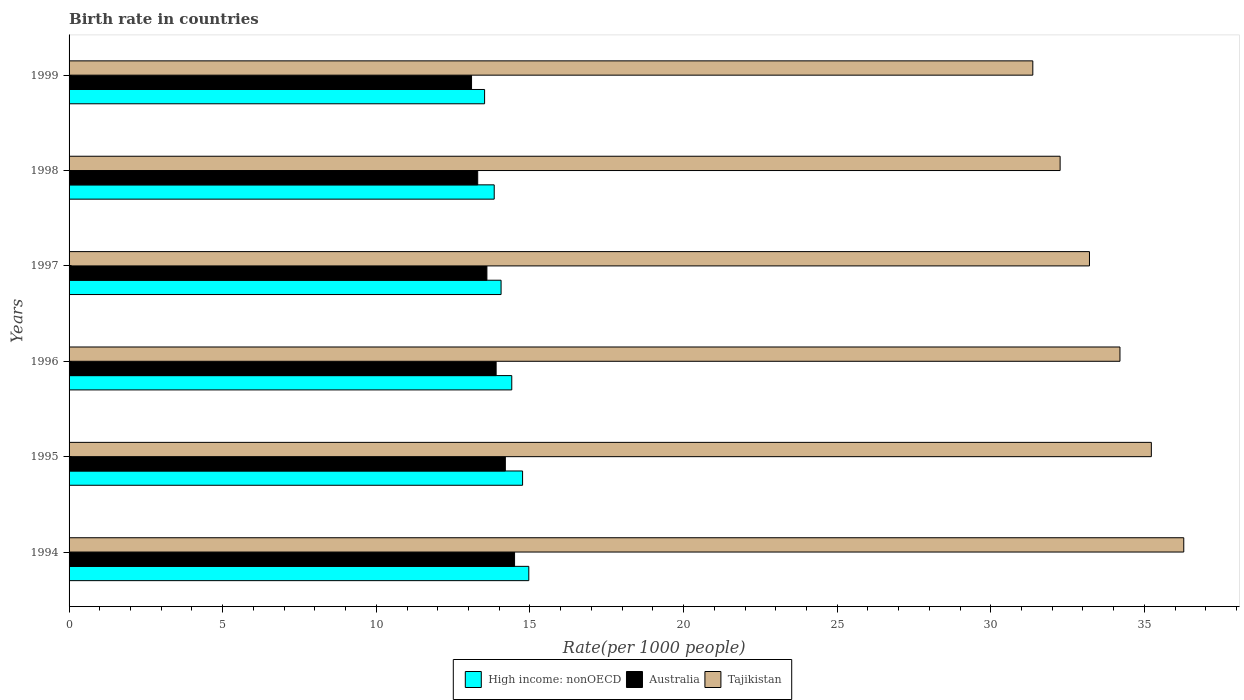In how many cases, is the number of bars for a given year not equal to the number of legend labels?
Ensure brevity in your answer.  0. What is the birth rate in Tajikistan in 1999?
Keep it short and to the point. 31.37. Across all years, what is the minimum birth rate in High income: nonOECD?
Ensure brevity in your answer.  13.52. In which year was the birth rate in Australia maximum?
Provide a short and direct response. 1994. What is the total birth rate in Tajikistan in the graph?
Ensure brevity in your answer.  202.55. What is the difference between the birth rate in Tajikistan in 1996 and that in 1998?
Provide a succinct answer. 1.95. What is the difference between the birth rate in Tajikistan in 1996 and the birth rate in Australia in 1995?
Your response must be concise. 20. What is the average birth rate in Australia per year?
Keep it short and to the point. 13.77. In the year 1995, what is the difference between the birth rate in Tajikistan and birth rate in Australia?
Keep it short and to the point. 21.03. What is the ratio of the birth rate in High income: nonOECD in 1995 to that in 1996?
Your answer should be very brief. 1.02. Is the difference between the birth rate in Tajikistan in 1995 and 1999 greater than the difference between the birth rate in Australia in 1995 and 1999?
Provide a short and direct response. Yes. What is the difference between the highest and the second highest birth rate in Australia?
Your answer should be compact. 0.3. What is the difference between the highest and the lowest birth rate in Tajikistan?
Your response must be concise. 4.91. Is the sum of the birth rate in High income: nonOECD in 1994 and 1998 greater than the maximum birth rate in Tajikistan across all years?
Give a very brief answer. No. What does the 3rd bar from the top in 1997 represents?
Offer a terse response. High income: nonOECD. What does the 3rd bar from the bottom in 1996 represents?
Keep it short and to the point. Tajikistan. How many years are there in the graph?
Provide a short and direct response. 6. Are the values on the major ticks of X-axis written in scientific E-notation?
Ensure brevity in your answer.  No. What is the title of the graph?
Your response must be concise. Birth rate in countries. Does "Maldives" appear as one of the legend labels in the graph?
Keep it short and to the point. No. What is the label or title of the X-axis?
Make the answer very short. Rate(per 1000 people). What is the label or title of the Y-axis?
Make the answer very short. Years. What is the Rate(per 1000 people) of High income: nonOECD in 1994?
Provide a short and direct response. 14.96. What is the Rate(per 1000 people) in Tajikistan in 1994?
Your answer should be compact. 36.28. What is the Rate(per 1000 people) in High income: nonOECD in 1995?
Make the answer very short. 14.76. What is the Rate(per 1000 people) in Australia in 1995?
Provide a succinct answer. 14.2. What is the Rate(per 1000 people) of Tajikistan in 1995?
Ensure brevity in your answer.  35.23. What is the Rate(per 1000 people) in High income: nonOECD in 1996?
Your answer should be compact. 14.41. What is the Rate(per 1000 people) in Australia in 1996?
Keep it short and to the point. 13.9. What is the Rate(per 1000 people) in Tajikistan in 1996?
Offer a very short reply. 34.2. What is the Rate(per 1000 people) of High income: nonOECD in 1997?
Offer a terse response. 14.06. What is the Rate(per 1000 people) of Tajikistan in 1997?
Provide a short and direct response. 33.21. What is the Rate(per 1000 people) in High income: nonOECD in 1998?
Provide a succinct answer. 13.84. What is the Rate(per 1000 people) of Australia in 1998?
Your answer should be very brief. 13.3. What is the Rate(per 1000 people) in Tajikistan in 1998?
Ensure brevity in your answer.  32.26. What is the Rate(per 1000 people) in High income: nonOECD in 1999?
Give a very brief answer. 13.52. What is the Rate(per 1000 people) of Tajikistan in 1999?
Offer a terse response. 31.37. Across all years, what is the maximum Rate(per 1000 people) of High income: nonOECD?
Your response must be concise. 14.96. Across all years, what is the maximum Rate(per 1000 people) of Australia?
Ensure brevity in your answer.  14.5. Across all years, what is the maximum Rate(per 1000 people) of Tajikistan?
Keep it short and to the point. 36.28. Across all years, what is the minimum Rate(per 1000 people) in High income: nonOECD?
Ensure brevity in your answer.  13.52. Across all years, what is the minimum Rate(per 1000 people) of Australia?
Make the answer very short. 13.1. Across all years, what is the minimum Rate(per 1000 people) in Tajikistan?
Provide a succinct answer. 31.37. What is the total Rate(per 1000 people) in High income: nonOECD in the graph?
Provide a succinct answer. 85.56. What is the total Rate(per 1000 people) in Australia in the graph?
Keep it short and to the point. 82.6. What is the total Rate(per 1000 people) of Tajikistan in the graph?
Offer a very short reply. 202.55. What is the difference between the Rate(per 1000 people) in High income: nonOECD in 1994 and that in 1995?
Your answer should be very brief. 0.2. What is the difference between the Rate(per 1000 people) in Tajikistan in 1994 and that in 1995?
Provide a short and direct response. 1.05. What is the difference between the Rate(per 1000 people) in High income: nonOECD in 1994 and that in 1996?
Your response must be concise. 0.55. What is the difference between the Rate(per 1000 people) of Tajikistan in 1994 and that in 1996?
Your answer should be very brief. 2.08. What is the difference between the Rate(per 1000 people) in High income: nonOECD in 1994 and that in 1997?
Provide a short and direct response. 0.9. What is the difference between the Rate(per 1000 people) of Tajikistan in 1994 and that in 1997?
Provide a succinct answer. 3.07. What is the difference between the Rate(per 1000 people) of High income: nonOECD in 1994 and that in 1998?
Your answer should be compact. 1.13. What is the difference between the Rate(per 1000 people) of Tajikistan in 1994 and that in 1998?
Offer a very short reply. 4.02. What is the difference between the Rate(per 1000 people) in High income: nonOECD in 1994 and that in 1999?
Provide a short and direct response. 1.44. What is the difference between the Rate(per 1000 people) of Australia in 1994 and that in 1999?
Your response must be concise. 1.4. What is the difference between the Rate(per 1000 people) in Tajikistan in 1994 and that in 1999?
Provide a succinct answer. 4.91. What is the difference between the Rate(per 1000 people) in High income: nonOECD in 1995 and that in 1996?
Your response must be concise. 0.35. What is the difference between the Rate(per 1000 people) in Australia in 1995 and that in 1996?
Your answer should be very brief. 0.3. What is the difference between the Rate(per 1000 people) of High income: nonOECD in 1995 and that in 1997?
Your answer should be compact. 0.7. What is the difference between the Rate(per 1000 people) in Tajikistan in 1995 and that in 1997?
Ensure brevity in your answer.  2.01. What is the difference between the Rate(per 1000 people) of High income: nonOECD in 1995 and that in 1998?
Offer a terse response. 0.92. What is the difference between the Rate(per 1000 people) of Australia in 1995 and that in 1998?
Offer a very short reply. 0.9. What is the difference between the Rate(per 1000 people) in Tajikistan in 1995 and that in 1998?
Give a very brief answer. 2.97. What is the difference between the Rate(per 1000 people) of High income: nonOECD in 1995 and that in 1999?
Ensure brevity in your answer.  1.24. What is the difference between the Rate(per 1000 people) of Tajikistan in 1995 and that in 1999?
Offer a terse response. 3.86. What is the difference between the Rate(per 1000 people) of High income: nonOECD in 1996 and that in 1997?
Provide a succinct answer. 0.35. What is the difference between the Rate(per 1000 people) in Tajikistan in 1996 and that in 1997?
Your answer should be compact. 0.99. What is the difference between the Rate(per 1000 people) in High income: nonOECD in 1996 and that in 1998?
Your response must be concise. 0.57. What is the difference between the Rate(per 1000 people) of Australia in 1996 and that in 1998?
Provide a succinct answer. 0.6. What is the difference between the Rate(per 1000 people) in Tajikistan in 1996 and that in 1998?
Provide a succinct answer. 1.95. What is the difference between the Rate(per 1000 people) of High income: nonOECD in 1996 and that in 1999?
Make the answer very short. 0.88. What is the difference between the Rate(per 1000 people) of Tajikistan in 1996 and that in 1999?
Your response must be concise. 2.84. What is the difference between the Rate(per 1000 people) of High income: nonOECD in 1997 and that in 1998?
Provide a succinct answer. 0.22. What is the difference between the Rate(per 1000 people) in Australia in 1997 and that in 1998?
Provide a short and direct response. 0.3. What is the difference between the Rate(per 1000 people) of Tajikistan in 1997 and that in 1998?
Give a very brief answer. 0.95. What is the difference between the Rate(per 1000 people) in High income: nonOECD in 1997 and that in 1999?
Ensure brevity in your answer.  0.54. What is the difference between the Rate(per 1000 people) of Tajikistan in 1997 and that in 1999?
Provide a short and direct response. 1.84. What is the difference between the Rate(per 1000 people) of High income: nonOECD in 1998 and that in 1999?
Give a very brief answer. 0.31. What is the difference between the Rate(per 1000 people) in Australia in 1998 and that in 1999?
Offer a terse response. 0.2. What is the difference between the Rate(per 1000 people) in Tajikistan in 1998 and that in 1999?
Your answer should be compact. 0.89. What is the difference between the Rate(per 1000 people) in High income: nonOECD in 1994 and the Rate(per 1000 people) in Australia in 1995?
Your response must be concise. 0.76. What is the difference between the Rate(per 1000 people) of High income: nonOECD in 1994 and the Rate(per 1000 people) of Tajikistan in 1995?
Provide a short and direct response. -20.26. What is the difference between the Rate(per 1000 people) in Australia in 1994 and the Rate(per 1000 people) in Tajikistan in 1995?
Give a very brief answer. -20.73. What is the difference between the Rate(per 1000 people) in High income: nonOECD in 1994 and the Rate(per 1000 people) in Australia in 1996?
Make the answer very short. 1.06. What is the difference between the Rate(per 1000 people) of High income: nonOECD in 1994 and the Rate(per 1000 people) of Tajikistan in 1996?
Ensure brevity in your answer.  -19.24. What is the difference between the Rate(per 1000 people) of Australia in 1994 and the Rate(per 1000 people) of Tajikistan in 1996?
Your response must be concise. -19.7. What is the difference between the Rate(per 1000 people) in High income: nonOECD in 1994 and the Rate(per 1000 people) in Australia in 1997?
Provide a short and direct response. 1.36. What is the difference between the Rate(per 1000 people) in High income: nonOECD in 1994 and the Rate(per 1000 people) in Tajikistan in 1997?
Offer a terse response. -18.25. What is the difference between the Rate(per 1000 people) in Australia in 1994 and the Rate(per 1000 people) in Tajikistan in 1997?
Provide a short and direct response. -18.71. What is the difference between the Rate(per 1000 people) in High income: nonOECD in 1994 and the Rate(per 1000 people) in Australia in 1998?
Give a very brief answer. 1.66. What is the difference between the Rate(per 1000 people) in High income: nonOECD in 1994 and the Rate(per 1000 people) in Tajikistan in 1998?
Make the answer very short. -17.29. What is the difference between the Rate(per 1000 people) in Australia in 1994 and the Rate(per 1000 people) in Tajikistan in 1998?
Provide a short and direct response. -17.76. What is the difference between the Rate(per 1000 people) in High income: nonOECD in 1994 and the Rate(per 1000 people) in Australia in 1999?
Your answer should be compact. 1.86. What is the difference between the Rate(per 1000 people) of High income: nonOECD in 1994 and the Rate(per 1000 people) of Tajikistan in 1999?
Give a very brief answer. -16.4. What is the difference between the Rate(per 1000 people) in Australia in 1994 and the Rate(per 1000 people) in Tajikistan in 1999?
Offer a very short reply. -16.87. What is the difference between the Rate(per 1000 people) in High income: nonOECD in 1995 and the Rate(per 1000 people) in Australia in 1996?
Your response must be concise. 0.86. What is the difference between the Rate(per 1000 people) of High income: nonOECD in 1995 and the Rate(per 1000 people) of Tajikistan in 1996?
Make the answer very short. -19.44. What is the difference between the Rate(per 1000 people) in Australia in 1995 and the Rate(per 1000 people) in Tajikistan in 1996?
Provide a succinct answer. -20. What is the difference between the Rate(per 1000 people) in High income: nonOECD in 1995 and the Rate(per 1000 people) in Australia in 1997?
Offer a terse response. 1.16. What is the difference between the Rate(per 1000 people) of High income: nonOECD in 1995 and the Rate(per 1000 people) of Tajikistan in 1997?
Your answer should be very brief. -18.45. What is the difference between the Rate(per 1000 people) of Australia in 1995 and the Rate(per 1000 people) of Tajikistan in 1997?
Make the answer very short. -19.01. What is the difference between the Rate(per 1000 people) of High income: nonOECD in 1995 and the Rate(per 1000 people) of Australia in 1998?
Offer a terse response. 1.46. What is the difference between the Rate(per 1000 people) in High income: nonOECD in 1995 and the Rate(per 1000 people) in Tajikistan in 1998?
Offer a very short reply. -17.5. What is the difference between the Rate(per 1000 people) in Australia in 1995 and the Rate(per 1000 people) in Tajikistan in 1998?
Your answer should be very brief. -18.06. What is the difference between the Rate(per 1000 people) in High income: nonOECD in 1995 and the Rate(per 1000 people) in Australia in 1999?
Provide a short and direct response. 1.66. What is the difference between the Rate(per 1000 people) of High income: nonOECD in 1995 and the Rate(per 1000 people) of Tajikistan in 1999?
Provide a succinct answer. -16.61. What is the difference between the Rate(per 1000 people) of Australia in 1995 and the Rate(per 1000 people) of Tajikistan in 1999?
Provide a short and direct response. -17.17. What is the difference between the Rate(per 1000 people) in High income: nonOECD in 1996 and the Rate(per 1000 people) in Australia in 1997?
Give a very brief answer. 0.81. What is the difference between the Rate(per 1000 people) of High income: nonOECD in 1996 and the Rate(per 1000 people) of Tajikistan in 1997?
Make the answer very short. -18.8. What is the difference between the Rate(per 1000 people) in Australia in 1996 and the Rate(per 1000 people) in Tajikistan in 1997?
Provide a succinct answer. -19.31. What is the difference between the Rate(per 1000 people) in High income: nonOECD in 1996 and the Rate(per 1000 people) in Australia in 1998?
Your answer should be very brief. 1.11. What is the difference between the Rate(per 1000 people) of High income: nonOECD in 1996 and the Rate(per 1000 people) of Tajikistan in 1998?
Your answer should be compact. -17.85. What is the difference between the Rate(per 1000 people) in Australia in 1996 and the Rate(per 1000 people) in Tajikistan in 1998?
Your response must be concise. -18.36. What is the difference between the Rate(per 1000 people) of High income: nonOECD in 1996 and the Rate(per 1000 people) of Australia in 1999?
Your response must be concise. 1.31. What is the difference between the Rate(per 1000 people) in High income: nonOECD in 1996 and the Rate(per 1000 people) in Tajikistan in 1999?
Make the answer very short. -16.96. What is the difference between the Rate(per 1000 people) of Australia in 1996 and the Rate(per 1000 people) of Tajikistan in 1999?
Your response must be concise. -17.47. What is the difference between the Rate(per 1000 people) of High income: nonOECD in 1997 and the Rate(per 1000 people) of Australia in 1998?
Provide a succinct answer. 0.76. What is the difference between the Rate(per 1000 people) of High income: nonOECD in 1997 and the Rate(per 1000 people) of Tajikistan in 1998?
Your answer should be compact. -18.2. What is the difference between the Rate(per 1000 people) in Australia in 1997 and the Rate(per 1000 people) in Tajikistan in 1998?
Provide a succinct answer. -18.66. What is the difference between the Rate(per 1000 people) in High income: nonOECD in 1997 and the Rate(per 1000 people) in Australia in 1999?
Provide a succinct answer. 0.96. What is the difference between the Rate(per 1000 people) in High income: nonOECD in 1997 and the Rate(per 1000 people) in Tajikistan in 1999?
Offer a very short reply. -17.31. What is the difference between the Rate(per 1000 people) in Australia in 1997 and the Rate(per 1000 people) in Tajikistan in 1999?
Your answer should be compact. -17.77. What is the difference between the Rate(per 1000 people) of High income: nonOECD in 1998 and the Rate(per 1000 people) of Australia in 1999?
Keep it short and to the point. 0.74. What is the difference between the Rate(per 1000 people) of High income: nonOECD in 1998 and the Rate(per 1000 people) of Tajikistan in 1999?
Provide a succinct answer. -17.53. What is the difference between the Rate(per 1000 people) in Australia in 1998 and the Rate(per 1000 people) in Tajikistan in 1999?
Your answer should be very brief. -18.07. What is the average Rate(per 1000 people) in High income: nonOECD per year?
Provide a succinct answer. 14.26. What is the average Rate(per 1000 people) of Australia per year?
Provide a succinct answer. 13.77. What is the average Rate(per 1000 people) of Tajikistan per year?
Give a very brief answer. 33.76. In the year 1994, what is the difference between the Rate(per 1000 people) in High income: nonOECD and Rate(per 1000 people) in Australia?
Keep it short and to the point. 0.46. In the year 1994, what is the difference between the Rate(per 1000 people) in High income: nonOECD and Rate(per 1000 people) in Tajikistan?
Your answer should be very brief. -21.32. In the year 1994, what is the difference between the Rate(per 1000 people) in Australia and Rate(per 1000 people) in Tajikistan?
Offer a very short reply. -21.78. In the year 1995, what is the difference between the Rate(per 1000 people) of High income: nonOECD and Rate(per 1000 people) of Australia?
Offer a very short reply. 0.56. In the year 1995, what is the difference between the Rate(per 1000 people) in High income: nonOECD and Rate(per 1000 people) in Tajikistan?
Offer a terse response. -20.47. In the year 1995, what is the difference between the Rate(per 1000 people) of Australia and Rate(per 1000 people) of Tajikistan?
Ensure brevity in your answer.  -21.03. In the year 1996, what is the difference between the Rate(per 1000 people) of High income: nonOECD and Rate(per 1000 people) of Australia?
Your answer should be compact. 0.51. In the year 1996, what is the difference between the Rate(per 1000 people) in High income: nonOECD and Rate(per 1000 people) in Tajikistan?
Offer a very short reply. -19.8. In the year 1996, what is the difference between the Rate(per 1000 people) of Australia and Rate(per 1000 people) of Tajikistan?
Give a very brief answer. -20.3. In the year 1997, what is the difference between the Rate(per 1000 people) in High income: nonOECD and Rate(per 1000 people) in Australia?
Offer a very short reply. 0.46. In the year 1997, what is the difference between the Rate(per 1000 people) in High income: nonOECD and Rate(per 1000 people) in Tajikistan?
Provide a succinct answer. -19.15. In the year 1997, what is the difference between the Rate(per 1000 people) of Australia and Rate(per 1000 people) of Tajikistan?
Your answer should be very brief. -19.61. In the year 1998, what is the difference between the Rate(per 1000 people) in High income: nonOECD and Rate(per 1000 people) in Australia?
Make the answer very short. 0.54. In the year 1998, what is the difference between the Rate(per 1000 people) in High income: nonOECD and Rate(per 1000 people) in Tajikistan?
Make the answer very short. -18.42. In the year 1998, what is the difference between the Rate(per 1000 people) in Australia and Rate(per 1000 people) in Tajikistan?
Keep it short and to the point. -18.96. In the year 1999, what is the difference between the Rate(per 1000 people) in High income: nonOECD and Rate(per 1000 people) in Australia?
Ensure brevity in your answer.  0.42. In the year 1999, what is the difference between the Rate(per 1000 people) in High income: nonOECD and Rate(per 1000 people) in Tajikistan?
Offer a terse response. -17.84. In the year 1999, what is the difference between the Rate(per 1000 people) in Australia and Rate(per 1000 people) in Tajikistan?
Your response must be concise. -18.27. What is the ratio of the Rate(per 1000 people) in High income: nonOECD in 1994 to that in 1995?
Give a very brief answer. 1.01. What is the ratio of the Rate(per 1000 people) of Australia in 1994 to that in 1995?
Keep it short and to the point. 1.02. What is the ratio of the Rate(per 1000 people) of Tajikistan in 1994 to that in 1995?
Offer a very short reply. 1.03. What is the ratio of the Rate(per 1000 people) of High income: nonOECD in 1994 to that in 1996?
Give a very brief answer. 1.04. What is the ratio of the Rate(per 1000 people) in Australia in 1994 to that in 1996?
Provide a succinct answer. 1.04. What is the ratio of the Rate(per 1000 people) of Tajikistan in 1994 to that in 1996?
Keep it short and to the point. 1.06. What is the ratio of the Rate(per 1000 people) of High income: nonOECD in 1994 to that in 1997?
Ensure brevity in your answer.  1.06. What is the ratio of the Rate(per 1000 people) of Australia in 1994 to that in 1997?
Provide a succinct answer. 1.07. What is the ratio of the Rate(per 1000 people) in Tajikistan in 1994 to that in 1997?
Provide a succinct answer. 1.09. What is the ratio of the Rate(per 1000 people) in High income: nonOECD in 1994 to that in 1998?
Your response must be concise. 1.08. What is the ratio of the Rate(per 1000 people) in Australia in 1994 to that in 1998?
Give a very brief answer. 1.09. What is the ratio of the Rate(per 1000 people) of Tajikistan in 1994 to that in 1998?
Keep it short and to the point. 1.12. What is the ratio of the Rate(per 1000 people) of High income: nonOECD in 1994 to that in 1999?
Provide a succinct answer. 1.11. What is the ratio of the Rate(per 1000 people) of Australia in 1994 to that in 1999?
Your answer should be very brief. 1.11. What is the ratio of the Rate(per 1000 people) in Tajikistan in 1994 to that in 1999?
Your answer should be very brief. 1.16. What is the ratio of the Rate(per 1000 people) of High income: nonOECD in 1995 to that in 1996?
Offer a very short reply. 1.02. What is the ratio of the Rate(per 1000 people) of Australia in 1995 to that in 1996?
Your answer should be compact. 1.02. What is the ratio of the Rate(per 1000 people) in Tajikistan in 1995 to that in 1996?
Provide a succinct answer. 1.03. What is the ratio of the Rate(per 1000 people) in High income: nonOECD in 1995 to that in 1997?
Give a very brief answer. 1.05. What is the ratio of the Rate(per 1000 people) in Australia in 1995 to that in 1997?
Give a very brief answer. 1.04. What is the ratio of the Rate(per 1000 people) in Tajikistan in 1995 to that in 1997?
Provide a short and direct response. 1.06. What is the ratio of the Rate(per 1000 people) in High income: nonOECD in 1995 to that in 1998?
Your answer should be compact. 1.07. What is the ratio of the Rate(per 1000 people) of Australia in 1995 to that in 1998?
Make the answer very short. 1.07. What is the ratio of the Rate(per 1000 people) in Tajikistan in 1995 to that in 1998?
Offer a very short reply. 1.09. What is the ratio of the Rate(per 1000 people) in High income: nonOECD in 1995 to that in 1999?
Offer a terse response. 1.09. What is the ratio of the Rate(per 1000 people) of Australia in 1995 to that in 1999?
Keep it short and to the point. 1.08. What is the ratio of the Rate(per 1000 people) in Tajikistan in 1995 to that in 1999?
Offer a terse response. 1.12. What is the ratio of the Rate(per 1000 people) of High income: nonOECD in 1996 to that in 1997?
Offer a terse response. 1.02. What is the ratio of the Rate(per 1000 people) in Australia in 1996 to that in 1997?
Keep it short and to the point. 1.02. What is the ratio of the Rate(per 1000 people) of Tajikistan in 1996 to that in 1997?
Ensure brevity in your answer.  1.03. What is the ratio of the Rate(per 1000 people) of High income: nonOECD in 1996 to that in 1998?
Offer a terse response. 1.04. What is the ratio of the Rate(per 1000 people) in Australia in 1996 to that in 1998?
Provide a succinct answer. 1.05. What is the ratio of the Rate(per 1000 people) of Tajikistan in 1996 to that in 1998?
Ensure brevity in your answer.  1.06. What is the ratio of the Rate(per 1000 people) in High income: nonOECD in 1996 to that in 1999?
Provide a succinct answer. 1.07. What is the ratio of the Rate(per 1000 people) in Australia in 1996 to that in 1999?
Make the answer very short. 1.06. What is the ratio of the Rate(per 1000 people) in Tajikistan in 1996 to that in 1999?
Make the answer very short. 1.09. What is the ratio of the Rate(per 1000 people) in High income: nonOECD in 1997 to that in 1998?
Your answer should be compact. 1.02. What is the ratio of the Rate(per 1000 people) of Australia in 1997 to that in 1998?
Keep it short and to the point. 1.02. What is the ratio of the Rate(per 1000 people) of Tajikistan in 1997 to that in 1998?
Your answer should be very brief. 1.03. What is the ratio of the Rate(per 1000 people) of High income: nonOECD in 1997 to that in 1999?
Keep it short and to the point. 1.04. What is the ratio of the Rate(per 1000 people) in Australia in 1997 to that in 1999?
Your answer should be compact. 1.04. What is the ratio of the Rate(per 1000 people) of Tajikistan in 1997 to that in 1999?
Provide a succinct answer. 1.06. What is the ratio of the Rate(per 1000 people) of High income: nonOECD in 1998 to that in 1999?
Your answer should be compact. 1.02. What is the ratio of the Rate(per 1000 people) in Australia in 1998 to that in 1999?
Your answer should be compact. 1.02. What is the ratio of the Rate(per 1000 people) in Tajikistan in 1998 to that in 1999?
Keep it short and to the point. 1.03. What is the difference between the highest and the second highest Rate(per 1000 people) of High income: nonOECD?
Offer a very short reply. 0.2. What is the difference between the highest and the second highest Rate(per 1000 people) in Tajikistan?
Provide a short and direct response. 1.05. What is the difference between the highest and the lowest Rate(per 1000 people) in High income: nonOECD?
Make the answer very short. 1.44. What is the difference between the highest and the lowest Rate(per 1000 people) of Tajikistan?
Offer a terse response. 4.91. 